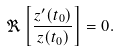Convert formula to latex. <formula><loc_0><loc_0><loc_500><loc_500>\Re \left [ \frac { z ^ { \prime } ( t _ { 0 } ) } { z ( t _ { 0 } ) } \right ] = 0 .</formula> 